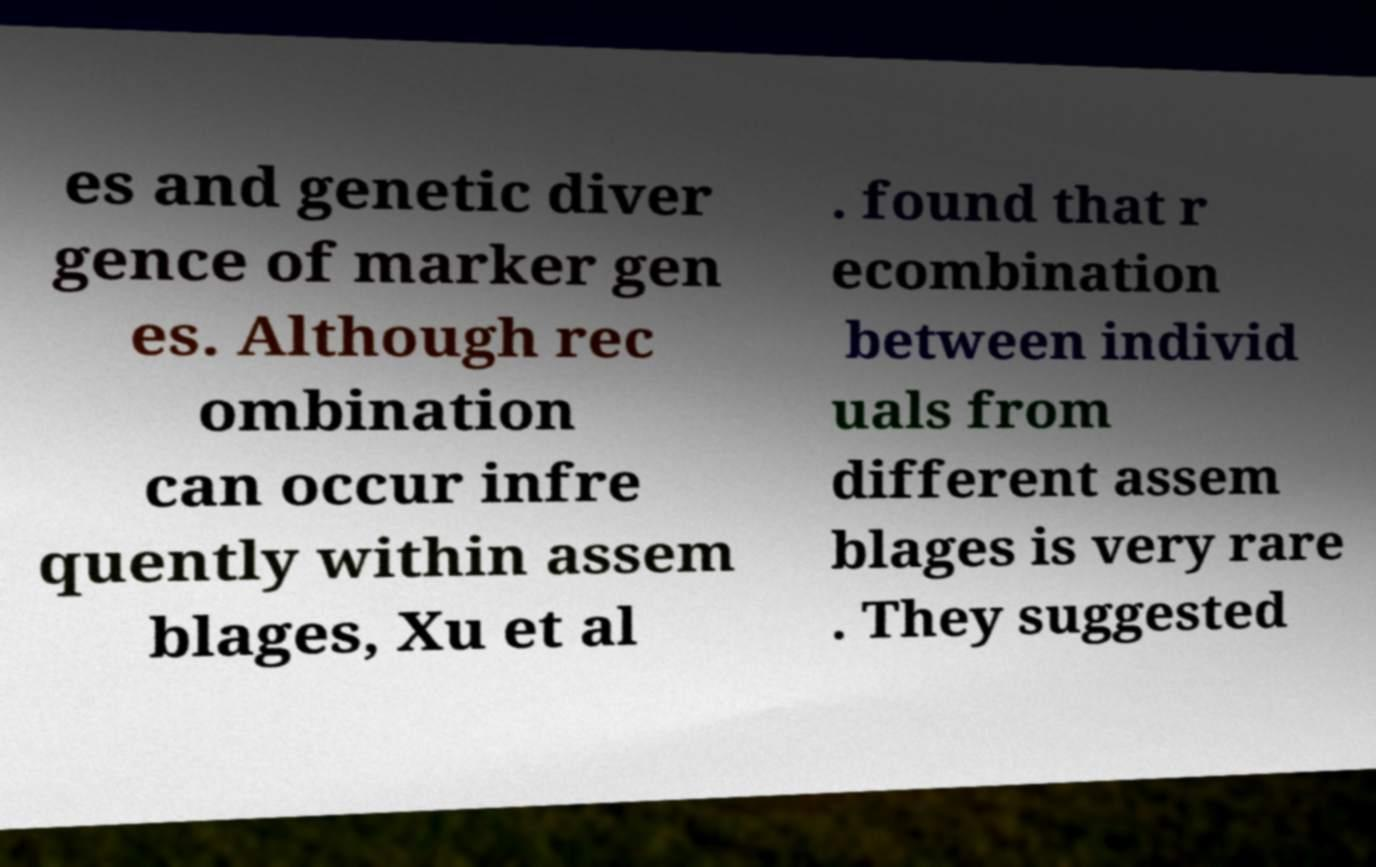Please identify and transcribe the text found in this image. es and genetic diver gence of marker gen es. Although rec ombination can occur infre quently within assem blages, Xu et al . found that r ecombination between individ uals from different assem blages is very rare . They suggested 